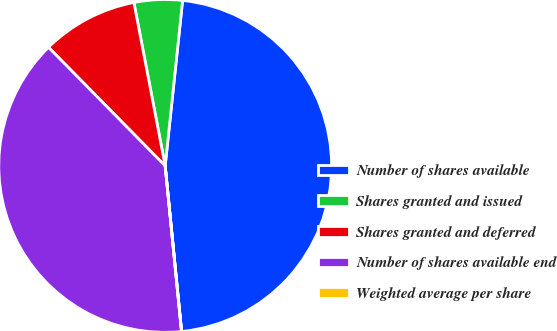<chart> <loc_0><loc_0><loc_500><loc_500><pie_chart><fcel>Number of shares available<fcel>Shares granted and issued<fcel>Shares granted and deferred<fcel>Number of shares available end<fcel>Weighted average per share<nl><fcel>46.75%<fcel>4.68%<fcel>9.36%<fcel>39.19%<fcel>0.01%<nl></chart> 